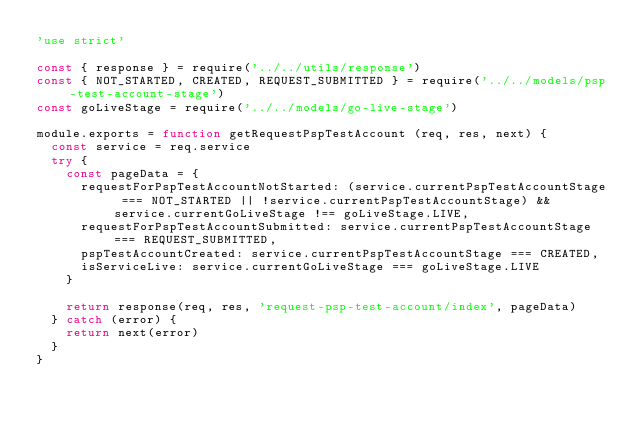<code> <loc_0><loc_0><loc_500><loc_500><_JavaScript_>'use strict'

const { response } = require('../../utils/response')
const { NOT_STARTED, CREATED, REQUEST_SUBMITTED } = require('../../models/psp-test-account-stage')
const goLiveStage = require('../../models/go-live-stage')

module.exports = function getRequestPspTestAccount (req, res, next) {
  const service = req.service
  try {
    const pageData = {
      requestForPspTestAccountNotStarted: (service.currentPspTestAccountStage === NOT_STARTED || !service.currentPspTestAccountStage) && service.currentGoLiveStage !== goLiveStage.LIVE,
      requestForPspTestAccountSubmitted: service.currentPspTestAccountStage === REQUEST_SUBMITTED,
      pspTestAccountCreated: service.currentPspTestAccountStage === CREATED,
      isServiceLive: service.currentGoLiveStage === goLiveStage.LIVE
    }

    return response(req, res, 'request-psp-test-account/index', pageData)
  } catch (error) {
    return next(error)
  }
}
</code> 